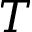Convert formula to latex. <formula><loc_0><loc_0><loc_500><loc_500>T</formula> 